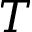Convert formula to latex. <formula><loc_0><loc_0><loc_500><loc_500>T</formula> 